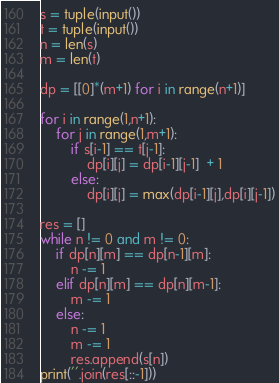<code> <loc_0><loc_0><loc_500><loc_500><_Python_>s = tuple(input())
t = tuple(input())
n = len(s)
m = len(t)

dp = [[0]*(m+1) for i in range(n+1)]

for i in range(1,n+1):
    for j in range(1,m+1):
        if s[i-1] == t[j-1]:
            dp[i][j] = dp[i-1][j-1]  + 1
        else:
            dp[i][j] = max(dp[i-1][j],dp[i][j-1])

res = []
while n != 0 and m != 0:
    if dp[n][m] == dp[n-1][m]:
        n -= 1
    elif dp[n][m] == dp[n][m-1]:
        m -= 1
    else:
        n -= 1
        m -= 1
        res.append(s[n])
print(''.join(res[::-1]))</code> 